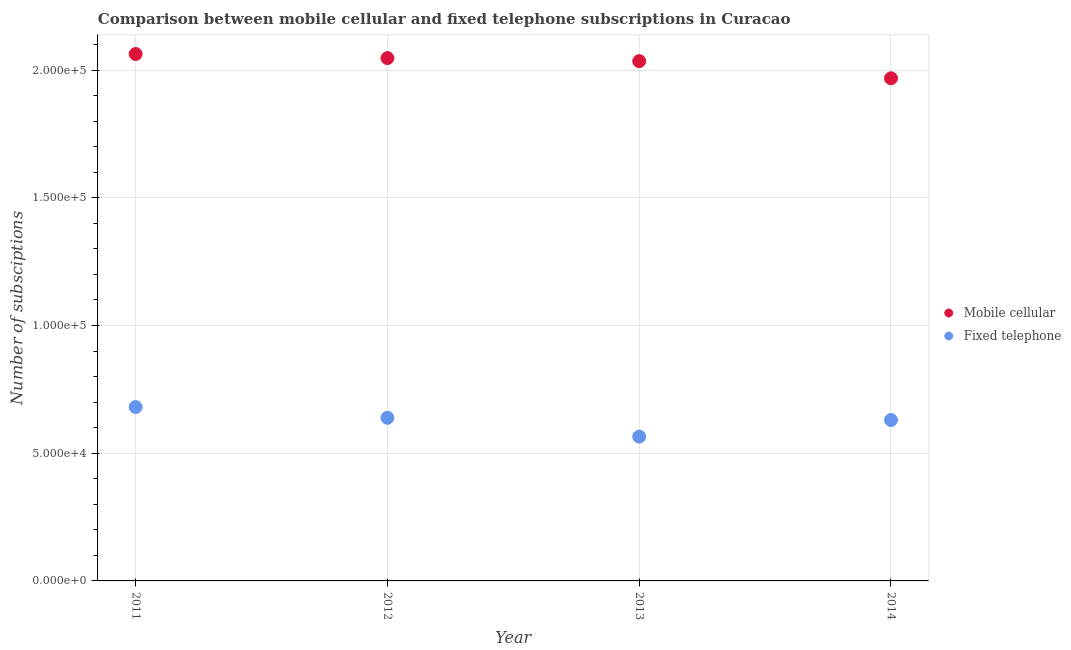What is the number of fixed telephone subscriptions in 2011?
Provide a short and direct response. 6.81e+04. Across all years, what is the maximum number of mobile cellular subscriptions?
Provide a short and direct response. 2.06e+05. Across all years, what is the minimum number of mobile cellular subscriptions?
Your answer should be very brief. 1.97e+05. What is the total number of mobile cellular subscriptions in the graph?
Your response must be concise. 8.11e+05. What is the difference between the number of mobile cellular subscriptions in 2011 and that in 2012?
Offer a terse response. 1592. What is the difference between the number of mobile cellular subscriptions in 2011 and the number of fixed telephone subscriptions in 2012?
Ensure brevity in your answer.  1.42e+05. What is the average number of mobile cellular subscriptions per year?
Your answer should be very brief. 2.03e+05. In the year 2011, what is the difference between the number of mobile cellular subscriptions and number of fixed telephone subscriptions?
Your answer should be very brief. 1.38e+05. In how many years, is the number of mobile cellular subscriptions greater than 90000?
Offer a terse response. 4. What is the ratio of the number of mobile cellular subscriptions in 2011 to that in 2012?
Ensure brevity in your answer.  1.01. Is the number of fixed telephone subscriptions in 2012 less than that in 2014?
Provide a short and direct response. No. What is the difference between the highest and the second highest number of mobile cellular subscriptions?
Make the answer very short. 1592. What is the difference between the highest and the lowest number of mobile cellular subscriptions?
Ensure brevity in your answer.  9507. Is the sum of the number of fixed telephone subscriptions in 2011 and 2013 greater than the maximum number of mobile cellular subscriptions across all years?
Provide a succinct answer. No. Is the number of fixed telephone subscriptions strictly less than the number of mobile cellular subscriptions over the years?
Keep it short and to the point. Yes. Does the graph contain grids?
Your answer should be very brief. Yes. Where does the legend appear in the graph?
Your answer should be very brief. Center right. What is the title of the graph?
Make the answer very short. Comparison between mobile cellular and fixed telephone subscriptions in Curacao. What is the label or title of the Y-axis?
Offer a terse response. Number of subsciptions. What is the Number of subsciptions of Mobile cellular in 2011?
Your answer should be compact. 2.06e+05. What is the Number of subsciptions of Fixed telephone in 2011?
Give a very brief answer. 6.81e+04. What is the Number of subsciptions in Mobile cellular in 2012?
Offer a very short reply. 2.05e+05. What is the Number of subsciptions of Fixed telephone in 2012?
Provide a succinct answer. 6.39e+04. What is the Number of subsciptions in Mobile cellular in 2013?
Give a very brief answer. 2.04e+05. What is the Number of subsciptions of Fixed telephone in 2013?
Provide a succinct answer. 5.65e+04. What is the Number of subsciptions in Mobile cellular in 2014?
Offer a terse response. 1.97e+05. What is the Number of subsciptions of Fixed telephone in 2014?
Your response must be concise. 6.30e+04. Across all years, what is the maximum Number of subsciptions of Mobile cellular?
Offer a terse response. 2.06e+05. Across all years, what is the maximum Number of subsciptions in Fixed telephone?
Your answer should be very brief. 6.81e+04. Across all years, what is the minimum Number of subsciptions of Mobile cellular?
Give a very brief answer. 1.97e+05. Across all years, what is the minimum Number of subsciptions in Fixed telephone?
Your answer should be compact. 5.65e+04. What is the total Number of subsciptions of Mobile cellular in the graph?
Ensure brevity in your answer.  8.11e+05. What is the total Number of subsciptions in Fixed telephone in the graph?
Provide a succinct answer. 2.51e+05. What is the difference between the Number of subsciptions of Mobile cellular in 2011 and that in 2012?
Your response must be concise. 1592. What is the difference between the Number of subsciptions in Fixed telephone in 2011 and that in 2012?
Your answer should be compact. 4202. What is the difference between the Number of subsciptions in Mobile cellular in 2011 and that in 2013?
Offer a very short reply. 2792. What is the difference between the Number of subsciptions in Fixed telephone in 2011 and that in 2013?
Ensure brevity in your answer.  1.16e+04. What is the difference between the Number of subsciptions of Mobile cellular in 2011 and that in 2014?
Give a very brief answer. 9507. What is the difference between the Number of subsciptions in Fixed telephone in 2011 and that in 2014?
Your answer should be very brief. 5070. What is the difference between the Number of subsciptions in Mobile cellular in 2012 and that in 2013?
Make the answer very short. 1200. What is the difference between the Number of subsciptions of Fixed telephone in 2012 and that in 2013?
Your answer should be compact. 7368. What is the difference between the Number of subsciptions of Mobile cellular in 2012 and that in 2014?
Provide a succinct answer. 7915. What is the difference between the Number of subsciptions of Fixed telephone in 2012 and that in 2014?
Offer a very short reply. 868. What is the difference between the Number of subsciptions in Mobile cellular in 2013 and that in 2014?
Keep it short and to the point. 6715. What is the difference between the Number of subsciptions of Fixed telephone in 2013 and that in 2014?
Your response must be concise. -6500. What is the difference between the Number of subsciptions in Mobile cellular in 2011 and the Number of subsciptions in Fixed telephone in 2012?
Offer a terse response. 1.42e+05. What is the difference between the Number of subsciptions of Mobile cellular in 2011 and the Number of subsciptions of Fixed telephone in 2013?
Offer a very short reply. 1.50e+05. What is the difference between the Number of subsciptions in Mobile cellular in 2011 and the Number of subsciptions in Fixed telephone in 2014?
Your answer should be very brief. 1.43e+05. What is the difference between the Number of subsciptions in Mobile cellular in 2012 and the Number of subsciptions in Fixed telephone in 2013?
Your answer should be very brief. 1.48e+05. What is the difference between the Number of subsciptions in Mobile cellular in 2012 and the Number of subsciptions in Fixed telephone in 2014?
Give a very brief answer. 1.42e+05. What is the difference between the Number of subsciptions in Mobile cellular in 2013 and the Number of subsciptions in Fixed telephone in 2014?
Offer a very short reply. 1.41e+05. What is the average Number of subsciptions in Mobile cellular per year?
Give a very brief answer. 2.03e+05. What is the average Number of subsciptions in Fixed telephone per year?
Offer a terse response. 6.29e+04. In the year 2011, what is the difference between the Number of subsciptions of Mobile cellular and Number of subsciptions of Fixed telephone?
Your response must be concise. 1.38e+05. In the year 2012, what is the difference between the Number of subsciptions in Mobile cellular and Number of subsciptions in Fixed telephone?
Your answer should be compact. 1.41e+05. In the year 2013, what is the difference between the Number of subsciptions in Mobile cellular and Number of subsciptions in Fixed telephone?
Offer a terse response. 1.47e+05. In the year 2014, what is the difference between the Number of subsciptions in Mobile cellular and Number of subsciptions in Fixed telephone?
Your answer should be compact. 1.34e+05. What is the ratio of the Number of subsciptions of Mobile cellular in 2011 to that in 2012?
Offer a very short reply. 1.01. What is the ratio of the Number of subsciptions of Fixed telephone in 2011 to that in 2012?
Your answer should be compact. 1.07. What is the ratio of the Number of subsciptions of Mobile cellular in 2011 to that in 2013?
Provide a succinct answer. 1.01. What is the ratio of the Number of subsciptions in Fixed telephone in 2011 to that in 2013?
Ensure brevity in your answer.  1.2. What is the ratio of the Number of subsciptions of Mobile cellular in 2011 to that in 2014?
Provide a short and direct response. 1.05. What is the ratio of the Number of subsciptions in Fixed telephone in 2011 to that in 2014?
Provide a succinct answer. 1.08. What is the ratio of the Number of subsciptions of Mobile cellular in 2012 to that in 2013?
Your answer should be very brief. 1.01. What is the ratio of the Number of subsciptions in Fixed telephone in 2012 to that in 2013?
Provide a short and direct response. 1.13. What is the ratio of the Number of subsciptions of Mobile cellular in 2012 to that in 2014?
Your answer should be very brief. 1.04. What is the ratio of the Number of subsciptions in Fixed telephone in 2012 to that in 2014?
Offer a terse response. 1.01. What is the ratio of the Number of subsciptions of Mobile cellular in 2013 to that in 2014?
Ensure brevity in your answer.  1.03. What is the ratio of the Number of subsciptions in Fixed telephone in 2013 to that in 2014?
Provide a short and direct response. 0.9. What is the difference between the highest and the second highest Number of subsciptions of Mobile cellular?
Your response must be concise. 1592. What is the difference between the highest and the second highest Number of subsciptions in Fixed telephone?
Your answer should be very brief. 4202. What is the difference between the highest and the lowest Number of subsciptions of Mobile cellular?
Make the answer very short. 9507. What is the difference between the highest and the lowest Number of subsciptions in Fixed telephone?
Your answer should be very brief. 1.16e+04. 